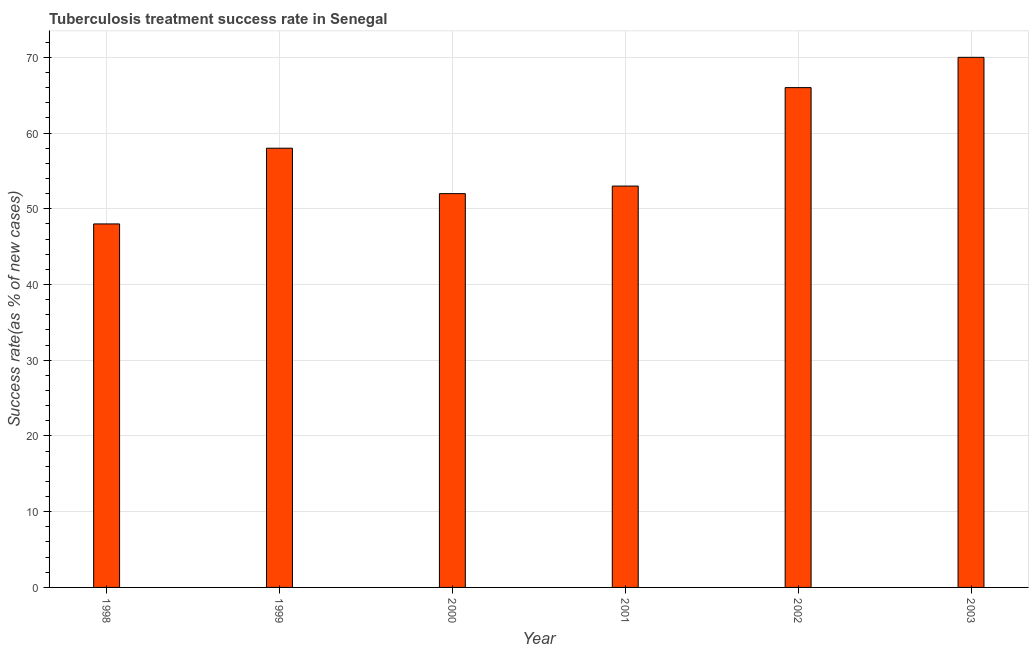Does the graph contain any zero values?
Your response must be concise. No. What is the title of the graph?
Ensure brevity in your answer.  Tuberculosis treatment success rate in Senegal. What is the label or title of the X-axis?
Give a very brief answer. Year. What is the label or title of the Y-axis?
Give a very brief answer. Success rate(as % of new cases). Across all years, what is the maximum tuberculosis treatment success rate?
Your response must be concise. 70. In which year was the tuberculosis treatment success rate maximum?
Ensure brevity in your answer.  2003. In which year was the tuberculosis treatment success rate minimum?
Keep it short and to the point. 1998. What is the sum of the tuberculosis treatment success rate?
Your response must be concise. 347. What is the difference between the tuberculosis treatment success rate in 1998 and 1999?
Your answer should be compact. -10. What is the average tuberculosis treatment success rate per year?
Your response must be concise. 57. What is the median tuberculosis treatment success rate?
Your answer should be compact. 55.5. In how many years, is the tuberculosis treatment success rate greater than 16 %?
Ensure brevity in your answer.  6. What is the ratio of the tuberculosis treatment success rate in 2002 to that in 2003?
Provide a succinct answer. 0.94. What is the difference between the highest and the second highest tuberculosis treatment success rate?
Your answer should be compact. 4. Is the sum of the tuberculosis treatment success rate in 1998 and 2001 greater than the maximum tuberculosis treatment success rate across all years?
Keep it short and to the point. Yes. What is the difference between the highest and the lowest tuberculosis treatment success rate?
Provide a short and direct response. 22. In how many years, is the tuberculosis treatment success rate greater than the average tuberculosis treatment success rate taken over all years?
Your response must be concise. 3. How many years are there in the graph?
Provide a succinct answer. 6. What is the Success rate(as % of new cases) in 1999?
Your answer should be compact. 58. What is the Success rate(as % of new cases) in 2002?
Make the answer very short. 66. What is the Success rate(as % of new cases) in 2003?
Offer a terse response. 70. What is the difference between the Success rate(as % of new cases) in 1998 and 2002?
Provide a short and direct response. -18. What is the difference between the Success rate(as % of new cases) in 1998 and 2003?
Ensure brevity in your answer.  -22. What is the difference between the Success rate(as % of new cases) in 1999 and 2000?
Offer a very short reply. 6. What is the difference between the Success rate(as % of new cases) in 1999 and 2001?
Your answer should be very brief. 5. What is the difference between the Success rate(as % of new cases) in 1999 and 2003?
Your answer should be compact. -12. What is the difference between the Success rate(as % of new cases) in 2000 and 2001?
Make the answer very short. -1. What is the difference between the Success rate(as % of new cases) in 2000 and 2002?
Your answer should be very brief. -14. What is the difference between the Success rate(as % of new cases) in 2000 and 2003?
Your response must be concise. -18. What is the difference between the Success rate(as % of new cases) in 2001 and 2002?
Ensure brevity in your answer.  -13. What is the ratio of the Success rate(as % of new cases) in 1998 to that in 1999?
Provide a succinct answer. 0.83. What is the ratio of the Success rate(as % of new cases) in 1998 to that in 2000?
Your response must be concise. 0.92. What is the ratio of the Success rate(as % of new cases) in 1998 to that in 2001?
Your answer should be compact. 0.91. What is the ratio of the Success rate(as % of new cases) in 1998 to that in 2002?
Give a very brief answer. 0.73. What is the ratio of the Success rate(as % of new cases) in 1998 to that in 2003?
Your answer should be very brief. 0.69. What is the ratio of the Success rate(as % of new cases) in 1999 to that in 2000?
Keep it short and to the point. 1.11. What is the ratio of the Success rate(as % of new cases) in 1999 to that in 2001?
Offer a very short reply. 1.09. What is the ratio of the Success rate(as % of new cases) in 1999 to that in 2002?
Offer a terse response. 0.88. What is the ratio of the Success rate(as % of new cases) in 1999 to that in 2003?
Your answer should be very brief. 0.83. What is the ratio of the Success rate(as % of new cases) in 2000 to that in 2001?
Offer a very short reply. 0.98. What is the ratio of the Success rate(as % of new cases) in 2000 to that in 2002?
Your answer should be compact. 0.79. What is the ratio of the Success rate(as % of new cases) in 2000 to that in 2003?
Provide a short and direct response. 0.74. What is the ratio of the Success rate(as % of new cases) in 2001 to that in 2002?
Your answer should be compact. 0.8. What is the ratio of the Success rate(as % of new cases) in 2001 to that in 2003?
Give a very brief answer. 0.76. What is the ratio of the Success rate(as % of new cases) in 2002 to that in 2003?
Offer a terse response. 0.94. 